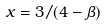<formula> <loc_0><loc_0><loc_500><loc_500>x = 3 / ( 4 - \beta )</formula> 